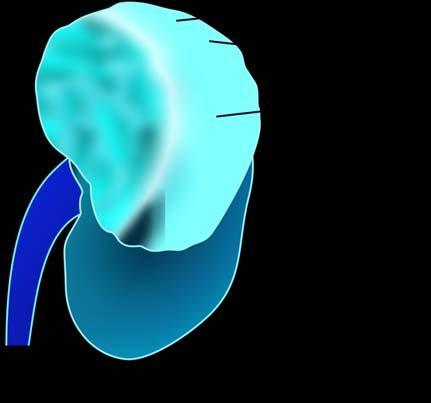does the margin of the colony show irregular, circumscribed, yellowish mass with areas of haemorrhages and necrosis?
Answer the question using a single word or phrase. No 